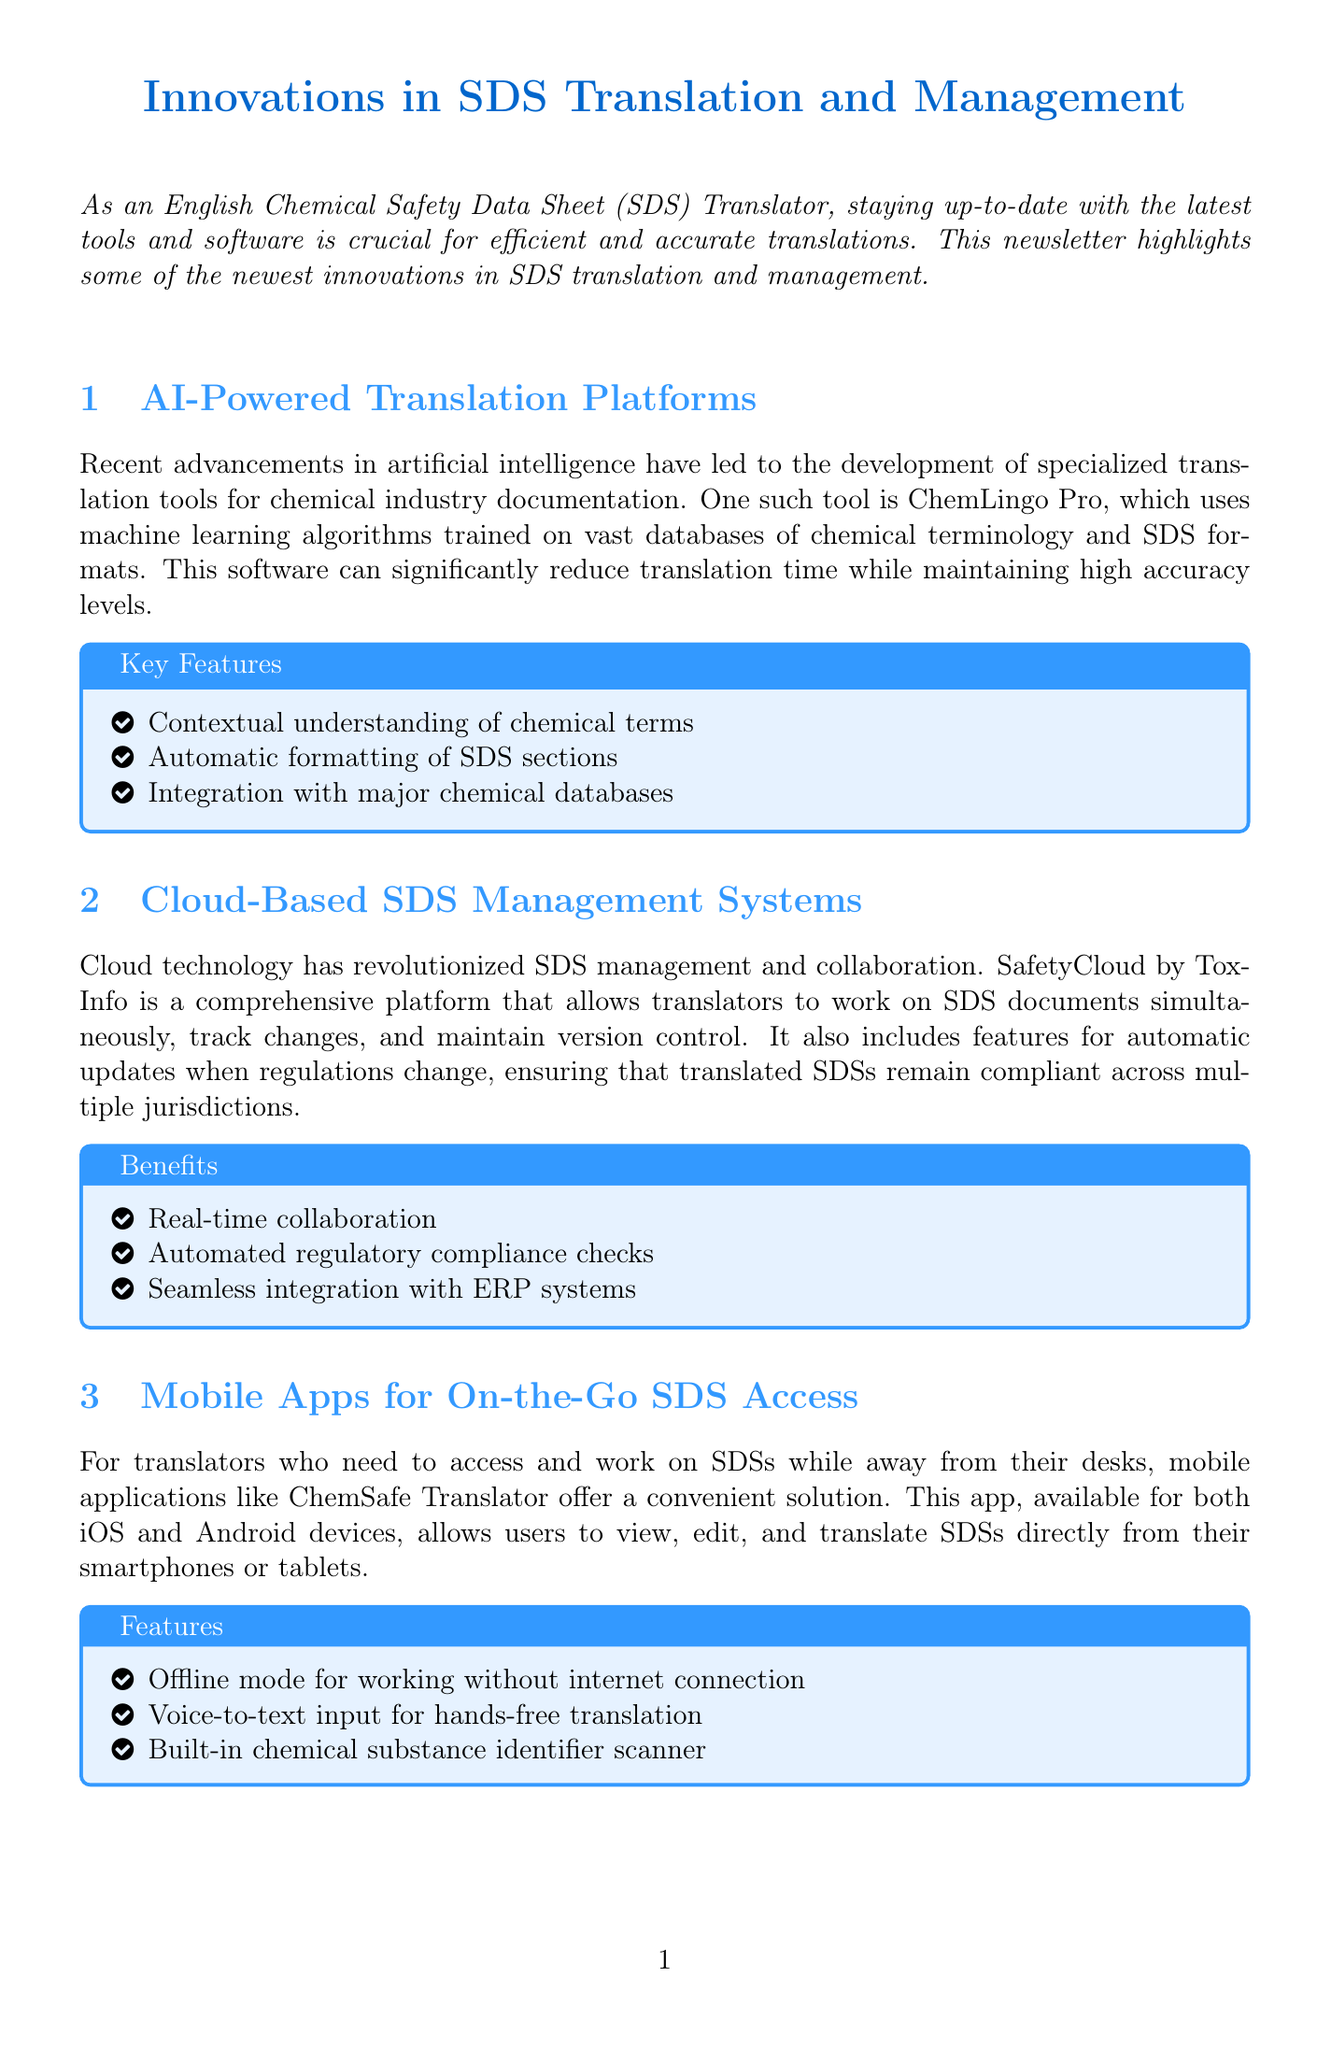What is the title of the newsletter? The title of the newsletter is stated at the beginning of the document.
Answer: Innovations in SDS Translation and Management What is the name of the AI-powered translation tool mentioned? The specific AI-powered tool highlighted in the newsletter is named in the relevant section.
Answer: ChemLingo Pro Which system allows simultaneous work on SDS documents? The system that enables real-time collaboration on SDS documents is mentioned clearly in the cloud management section.
Answer: SafetyCloud What feature is included in ChemSafe Translator for hands-free use? The mobile app's feature that allows voice input is explained under the features section.
Answer: Voice-to-text input What is a key benefit of cloud-based SDS management systems? The benefits of using cloud-based systems are detailed, including one that highlights an important aspect of compliance.
Answer: Automated regulatory compliance checks What version of MultiTerm is mentioned? The version of the terminology management tool is indicated in the section about terminology management.
Answer: Latest version What is a primary focus of terminology management tools? The overall aim of these tools is discussed in the provided content, which emphasizes consistency in translations.
Answer: Consistent use of terminology What technology trend is shaping SDS management? The introduction mentions a broader trend that has influenced how SDS management is conducted.
Answer: Cloud technology Who is the author of the newsletter? The authorship is indicated at the end of the document, summarizing their expertise.
Answer: An experienced English Chemical Safety Data Sheet (SDS) Translator 